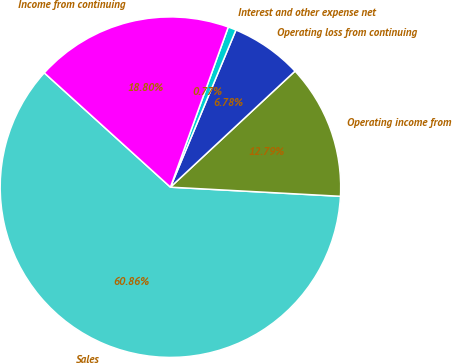Convert chart to OTSL. <chart><loc_0><loc_0><loc_500><loc_500><pie_chart><fcel>Sales<fcel>Operating income from<fcel>Operating loss from continuing<fcel>Interest and other expense net<fcel>Income from continuing<nl><fcel>60.86%<fcel>12.79%<fcel>6.78%<fcel>0.77%<fcel>18.8%<nl></chart> 